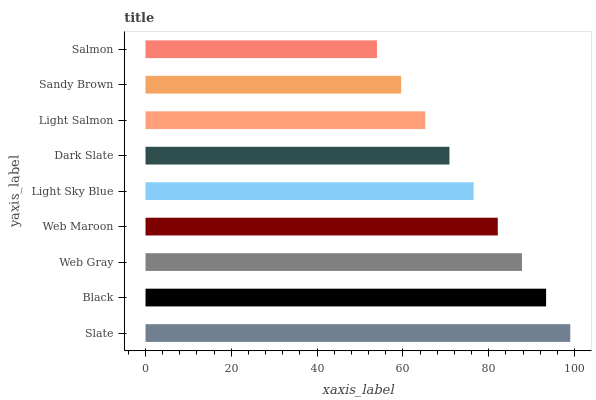Is Salmon the minimum?
Answer yes or no. Yes. Is Slate the maximum?
Answer yes or no. Yes. Is Black the minimum?
Answer yes or no. No. Is Black the maximum?
Answer yes or no. No. Is Slate greater than Black?
Answer yes or no. Yes. Is Black less than Slate?
Answer yes or no. Yes. Is Black greater than Slate?
Answer yes or no. No. Is Slate less than Black?
Answer yes or no. No. Is Light Sky Blue the high median?
Answer yes or no. Yes. Is Light Sky Blue the low median?
Answer yes or no. Yes. Is Slate the high median?
Answer yes or no. No. Is Sandy Brown the low median?
Answer yes or no. No. 